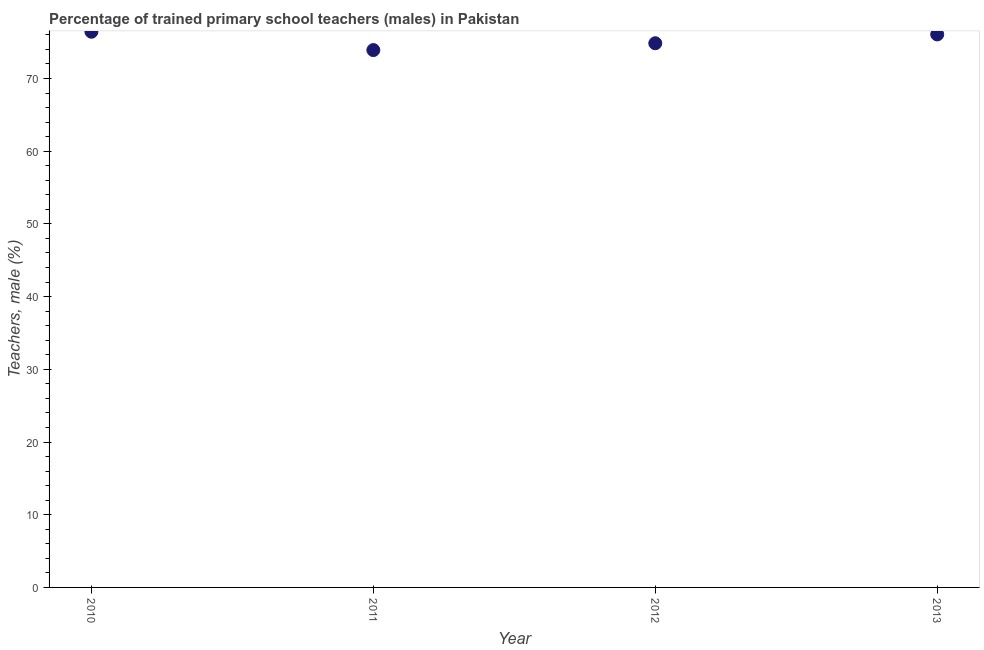What is the percentage of trained male teachers in 2012?
Provide a short and direct response. 74.85. Across all years, what is the maximum percentage of trained male teachers?
Provide a succinct answer. 76.43. Across all years, what is the minimum percentage of trained male teachers?
Keep it short and to the point. 73.91. In which year was the percentage of trained male teachers maximum?
Keep it short and to the point. 2010. What is the sum of the percentage of trained male teachers?
Your response must be concise. 301.24. What is the difference between the percentage of trained male teachers in 2010 and 2013?
Your answer should be compact. 0.37. What is the average percentage of trained male teachers per year?
Offer a terse response. 75.31. What is the median percentage of trained male teachers?
Provide a succinct answer. 75.45. Do a majority of the years between 2011 and 2010 (inclusive) have percentage of trained male teachers greater than 62 %?
Offer a very short reply. No. What is the ratio of the percentage of trained male teachers in 2010 to that in 2011?
Your answer should be compact. 1.03. Is the percentage of trained male teachers in 2011 less than that in 2012?
Your answer should be compact. Yes. Is the difference between the percentage of trained male teachers in 2011 and 2013 greater than the difference between any two years?
Offer a terse response. No. What is the difference between the highest and the second highest percentage of trained male teachers?
Your answer should be compact. 0.37. Is the sum of the percentage of trained male teachers in 2011 and 2013 greater than the maximum percentage of trained male teachers across all years?
Provide a succinct answer. Yes. What is the difference between the highest and the lowest percentage of trained male teachers?
Offer a very short reply. 2.52. How many dotlines are there?
Make the answer very short. 1. How many years are there in the graph?
Your response must be concise. 4. Does the graph contain any zero values?
Offer a terse response. No. What is the title of the graph?
Provide a succinct answer. Percentage of trained primary school teachers (males) in Pakistan. What is the label or title of the Y-axis?
Offer a very short reply. Teachers, male (%). What is the Teachers, male (%) in 2010?
Provide a short and direct response. 76.43. What is the Teachers, male (%) in 2011?
Your answer should be very brief. 73.91. What is the Teachers, male (%) in 2012?
Your response must be concise. 74.85. What is the Teachers, male (%) in 2013?
Offer a very short reply. 76.06. What is the difference between the Teachers, male (%) in 2010 and 2011?
Keep it short and to the point. 2.52. What is the difference between the Teachers, male (%) in 2010 and 2012?
Your response must be concise. 1.58. What is the difference between the Teachers, male (%) in 2010 and 2013?
Your answer should be compact. 0.37. What is the difference between the Teachers, male (%) in 2011 and 2012?
Your answer should be compact. -0.94. What is the difference between the Teachers, male (%) in 2011 and 2013?
Make the answer very short. -2.15. What is the difference between the Teachers, male (%) in 2012 and 2013?
Offer a terse response. -1.21. What is the ratio of the Teachers, male (%) in 2010 to that in 2011?
Provide a succinct answer. 1.03. What is the ratio of the Teachers, male (%) in 2010 to that in 2012?
Your answer should be very brief. 1.02. What is the ratio of the Teachers, male (%) in 2010 to that in 2013?
Keep it short and to the point. 1. 